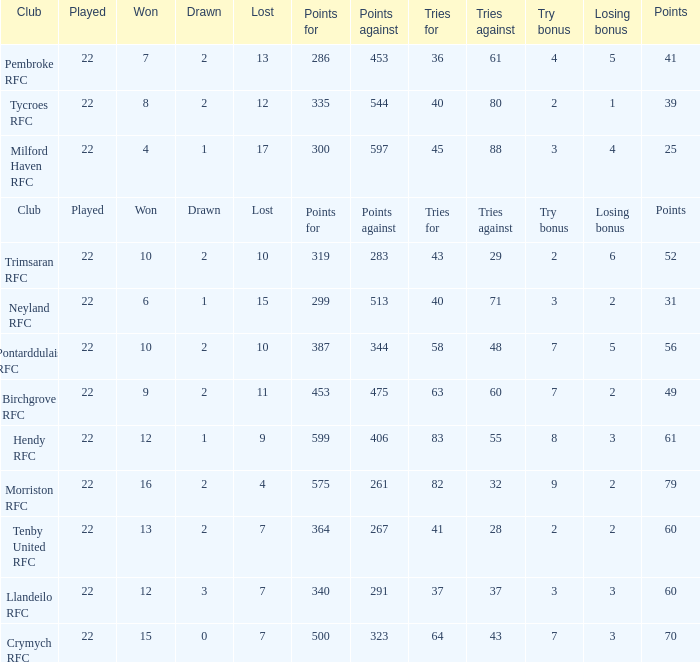What's the won with try bonus being 8 12.0. 